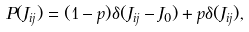Convert formula to latex. <formula><loc_0><loc_0><loc_500><loc_500>P ( J _ { i j } ) = ( 1 - p ) \delta ( J _ { i j } - J _ { 0 } ) + p \delta ( J _ { i j } ) ,</formula> 